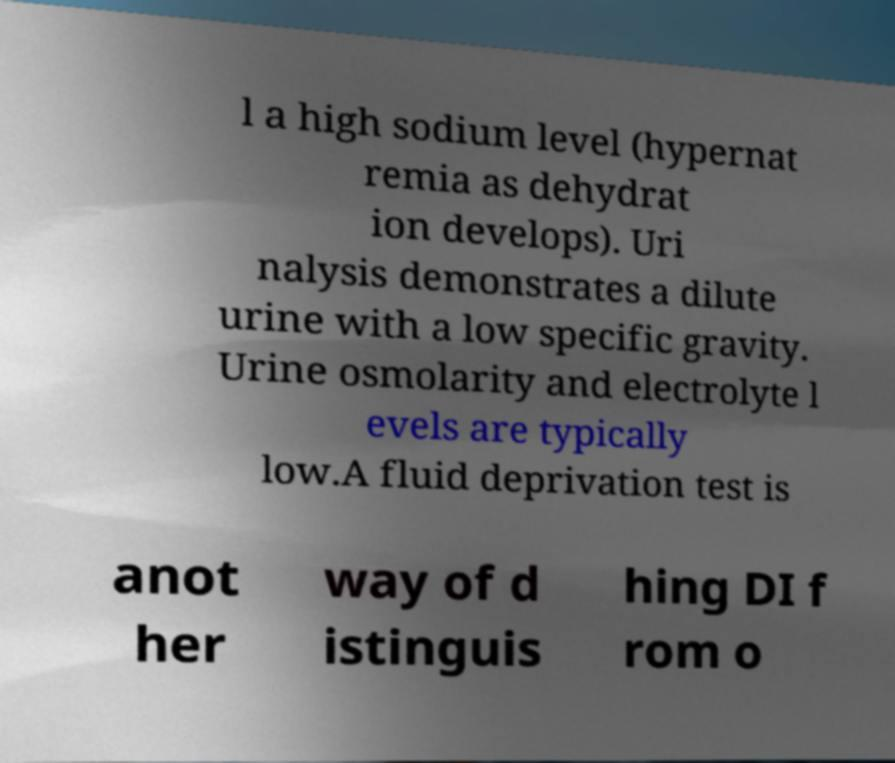I need the written content from this picture converted into text. Can you do that? l a high sodium level (hypernat remia as dehydrat ion develops). Uri nalysis demonstrates a dilute urine with a low specific gravity. Urine osmolarity and electrolyte l evels are typically low.A fluid deprivation test is anot her way of d istinguis hing DI f rom o 